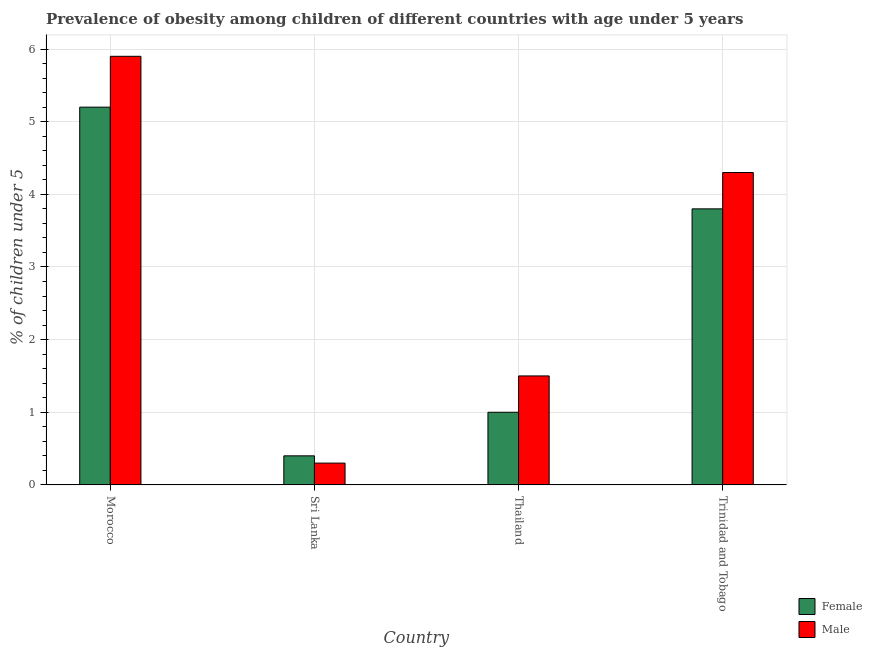How many different coloured bars are there?
Offer a very short reply. 2. Are the number of bars per tick equal to the number of legend labels?
Provide a succinct answer. Yes. How many bars are there on the 2nd tick from the right?
Give a very brief answer. 2. What is the label of the 3rd group of bars from the left?
Your response must be concise. Thailand. What is the percentage of obese male children in Trinidad and Tobago?
Offer a very short reply. 4.3. Across all countries, what is the maximum percentage of obese female children?
Ensure brevity in your answer.  5.2. Across all countries, what is the minimum percentage of obese female children?
Ensure brevity in your answer.  0.4. In which country was the percentage of obese male children maximum?
Provide a succinct answer. Morocco. In which country was the percentage of obese male children minimum?
Make the answer very short. Sri Lanka. What is the total percentage of obese female children in the graph?
Your answer should be very brief. 10.4. What is the difference between the percentage of obese female children in Thailand and that in Trinidad and Tobago?
Provide a succinct answer. -2.8. What is the difference between the percentage of obese female children in Sri Lanka and the percentage of obese male children in Trinidad and Tobago?
Offer a very short reply. -3.9. What is the average percentage of obese male children per country?
Make the answer very short. 3. What is the difference between the percentage of obese female children and percentage of obese male children in Sri Lanka?
Provide a succinct answer. 0.1. In how many countries, is the percentage of obese female children greater than 3.4 %?
Offer a very short reply. 2. What is the ratio of the percentage of obese female children in Morocco to that in Thailand?
Provide a succinct answer. 5.2. Is the percentage of obese male children in Thailand less than that in Trinidad and Tobago?
Provide a short and direct response. Yes. What is the difference between the highest and the second highest percentage of obese male children?
Your response must be concise. 1.6. What is the difference between the highest and the lowest percentage of obese male children?
Offer a terse response. 5.6. In how many countries, is the percentage of obese female children greater than the average percentage of obese female children taken over all countries?
Provide a short and direct response. 2. Is the sum of the percentage of obese male children in Morocco and Trinidad and Tobago greater than the maximum percentage of obese female children across all countries?
Your answer should be compact. Yes. What does the 1st bar from the left in Trinidad and Tobago represents?
Give a very brief answer. Female. What does the 1st bar from the right in Morocco represents?
Offer a very short reply. Male. Are all the bars in the graph horizontal?
Keep it short and to the point. No. How many countries are there in the graph?
Give a very brief answer. 4. Does the graph contain grids?
Provide a short and direct response. Yes. Where does the legend appear in the graph?
Keep it short and to the point. Bottom right. What is the title of the graph?
Provide a succinct answer. Prevalence of obesity among children of different countries with age under 5 years. Does "Net savings(excluding particulate emission damage)" appear as one of the legend labels in the graph?
Offer a very short reply. No. What is the label or title of the Y-axis?
Ensure brevity in your answer.   % of children under 5. What is the  % of children under 5 of Female in Morocco?
Offer a very short reply. 5.2. What is the  % of children under 5 in Male in Morocco?
Ensure brevity in your answer.  5.9. What is the  % of children under 5 of Female in Sri Lanka?
Your response must be concise. 0.4. What is the  % of children under 5 of Male in Sri Lanka?
Your answer should be compact. 0.3. What is the  % of children under 5 in Male in Thailand?
Ensure brevity in your answer.  1.5. What is the  % of children under 5 of Female in Trinidad and Tobago?
Ensure brevity in your answer.  3.8. What is the  % of children under 5 of Male in Trinidad and Tobago?
Offer a very short reply. 4.3. Across all countries, what is the maximum  % of children under 5 in Female?
Your response must be concise. 5.2. Across all countries, what is the maximum  % of children under 5 of Male?
Your answer should be very brief. 5.9. Across all countries, what is the minimum  % of children under 5 in Female?
Provide a short and direct response. 0.4. Across all countries, what is the minimum  % of children under 5 in Male?
Your answer should be compact. 0.3. What is the total  % of children under 5 of Female in the graph?
Your answer should be very brief. 10.4. What is the total  % of children under 5 in Male in the graph?
Your response must be concise. 12. What is the difference between the  % of children under 5 in Female in Morocco and that in Sri Lanka?
Keep it short and to the point. 4.8. What is the difference between the  % of children under 5 of Male in Morocco and that in Trinidad and Tobago?
Keep it short and to the point. 1.6. What is the difference between the  % of children under 5 in Female in Sri Lanka and that in Thailand?
Keep it short and to the point. -0.6. What is the difference between the  % of children under 5 of Male in Sri Lanka and that in Thailand?
Your answer should be compact. -1.2. What is the difference between the  % of children under 5 in Female in Sri Lanka and that in Trinidad and Tobago?
Offer a very short reply. -3.4. What is the difference between the  % of children under 5 of Female in Morocco and the  % of children under 5 of Male in Sri Lanka?
Make the answer very short. 4.9. What is the difference between the  % of children under 5 in Female in Morocco and the  % of children under 5 in Male in Thailand?
Give a very brief answer. 3.7. What is the difference between the  % of children under 5 of Female in Sri Lanka and the  % of children under 5 of Male in Trinidad and Tobago?
Your response must be concise. -3.9. What is the average  % of children under 5 of Male per country?
Ensure brevity in your answer.  3. What is the difference between the  % of children under 5 of Female and  % of children under 5 of Male in Morocco?
Offer a terse response. -0.7. What is the difference between the  % of children under 5 in Female and  % of children under 5 in Male in Sri Lanka?
Make the answer very short. 0.1. What is the difference between the  % of children under 5 in Female and  % of children under 5 in Male in Thailand?
Ensure brevity in your answer.  -0.5. What is the ratio of the  % of children under 5 in Female in Morocco to that in Sri Lanka?
Your response must be concise. 13. What is the ratio of the  % of children under 5 of Male in Morocco to that in Sri Lanka?
Provide a succinct answer. 19.67. What is the ratio of the  % of children under 5 in Female in Morocco to that in Thailand?
Make the answer very short. 5.2. What is the ratio of the  % of children under 5 of Male in Morocco to that in Thailand?
Make the answer very short. 3.93. What is the ratio of the  % of children under 5 of Female in Morocco to that in Trinidad and Tobago?
Provide a succinct answer. 1.37. What is the ratio of the  % of children under 5 of Male in Morocco to that in Trinidad and Tobago?
Ensure brevity in your answer.  1.37. What is the ratio of the  % of children under 5 in Female in Sri Lanka to that in Trinidad and Tobago?
Make the answer very short. 0.11. What is the ratio of the  % of children under 5 in Male in Sri Lanka to that in Trinidad and Tobago?
Your answer should be compact. 0.07. What is the ratio of the  % of children under 5 of Female in Thailand to that in Trinidad and Tobago?
Provide a short and direct response. 0.26. What is the ratio of the  % of children under 5 in Male in Thailand to that in Trinidad and Tobago?
Provide a short and direct response. 0.35. What is the difference between the highest and the second highest  % of children under 5 in Female?
Provide a short and direct response. 1.4. What is the difference between the highest and the lowest  % of children under 5 of Female?
Offer a very short reply. 4.8. 